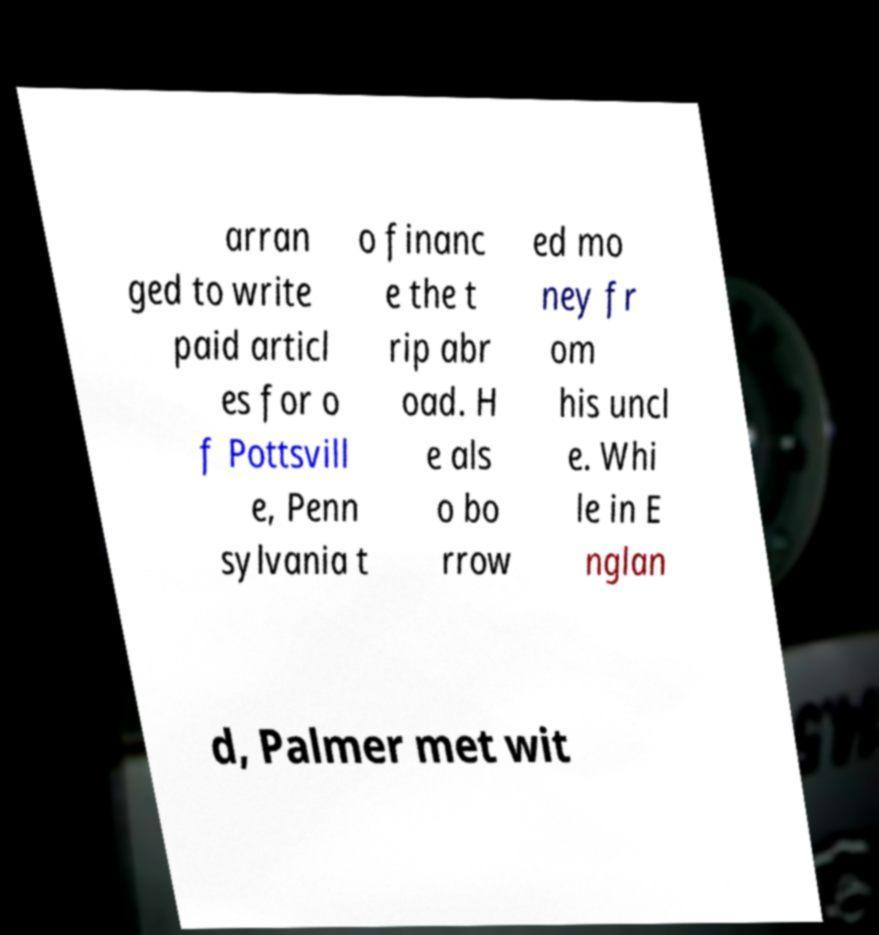Can you read and provide the text displayed in the image?This photo seems to have some interesting text. Can you extract and type it out for me? arran ged to write paid articl es for o f Pottsvill e, Penn sylvania t o financ e the t rip abr oad. H e als o bo rrow ed mo ney fr om his uncl e. Whi le in E nglan d, Palmer met wit 